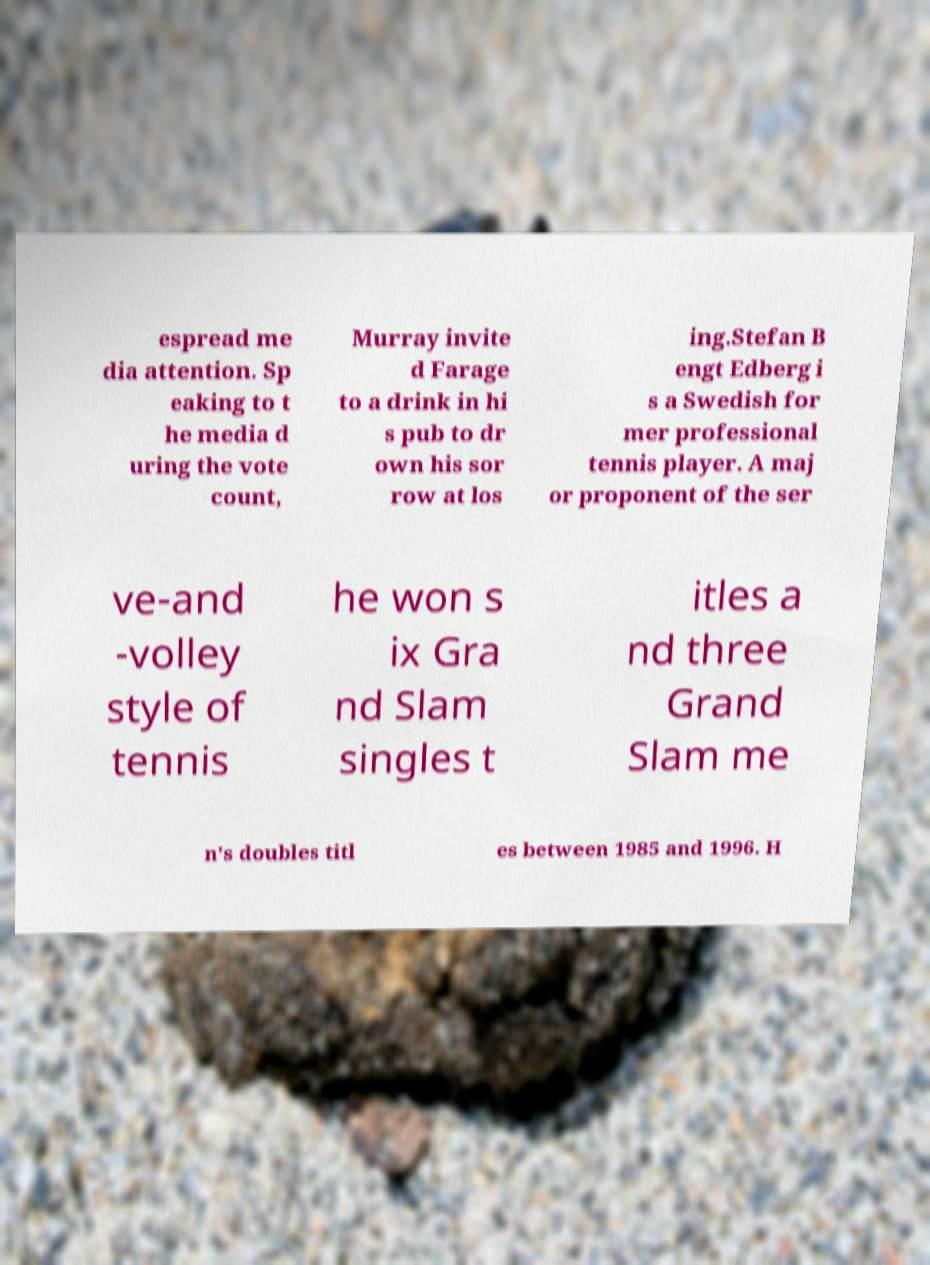Can you read and provide the text displayed in the image?This photo seems to have some interesting text. Can you extract and type it out for me? espread me dia attention. Sp eaking to t he media d uring the vote count, Murray invite d Farage to a drink in hi s pub to dr own his sor row at los ing.Stefan B engt Edberg i s a Swedish for mer professional tennis player. A maj or proponent of the ser ve-and -volley style of tennis he won s ix Gra nd Slam singles t itles a nd three Grand Slam me n's doubles titl es between 1985 and 1996. H 